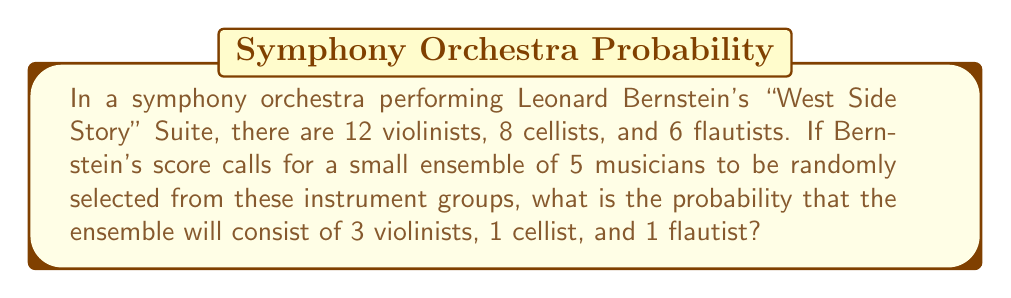Help me with this question. Let's approach this step-by-step:

1) First, we need to calculate the total number of ways to select 5 musicians from the 26 total (12 + 8 + 6 = 26). This is given by the combination formula:

   $$\binom{26}{5} = \frac{26!}{5!(26-5)!} = \frac{26!}{5!21!} = 65,780$$

2) Now, we need to calculate the number of ways to select 3 violinists out of 12, 1 cellist out of 8, and 1 flautist out of 6. These are also given by combination formulas:

   Violinists: $$\binom{12}{3} = \frac{12!}{3!9!} = 220$$
   Cellists: $$\binom{8}{1} = 8$$
   Flautists: $$\binom{6}{1} = 6$$

3) The total number of ways to select this specific combination is the product of these individual combinations:

   $$220 \times 8 \times 6 = 10,560$$

4) The probability is then the number of favorable outcomes divided by the total number of possible outcomes:

   $$P(\text{3 violinists, 1 cellist, 1 flautist}) = \frac{10,560}{65,780} = \frac{160}{999} \approx 0.1601$$
Answer: The probability is $\frac{160}{999}$ or approximately 0.1601 (16.01%). 